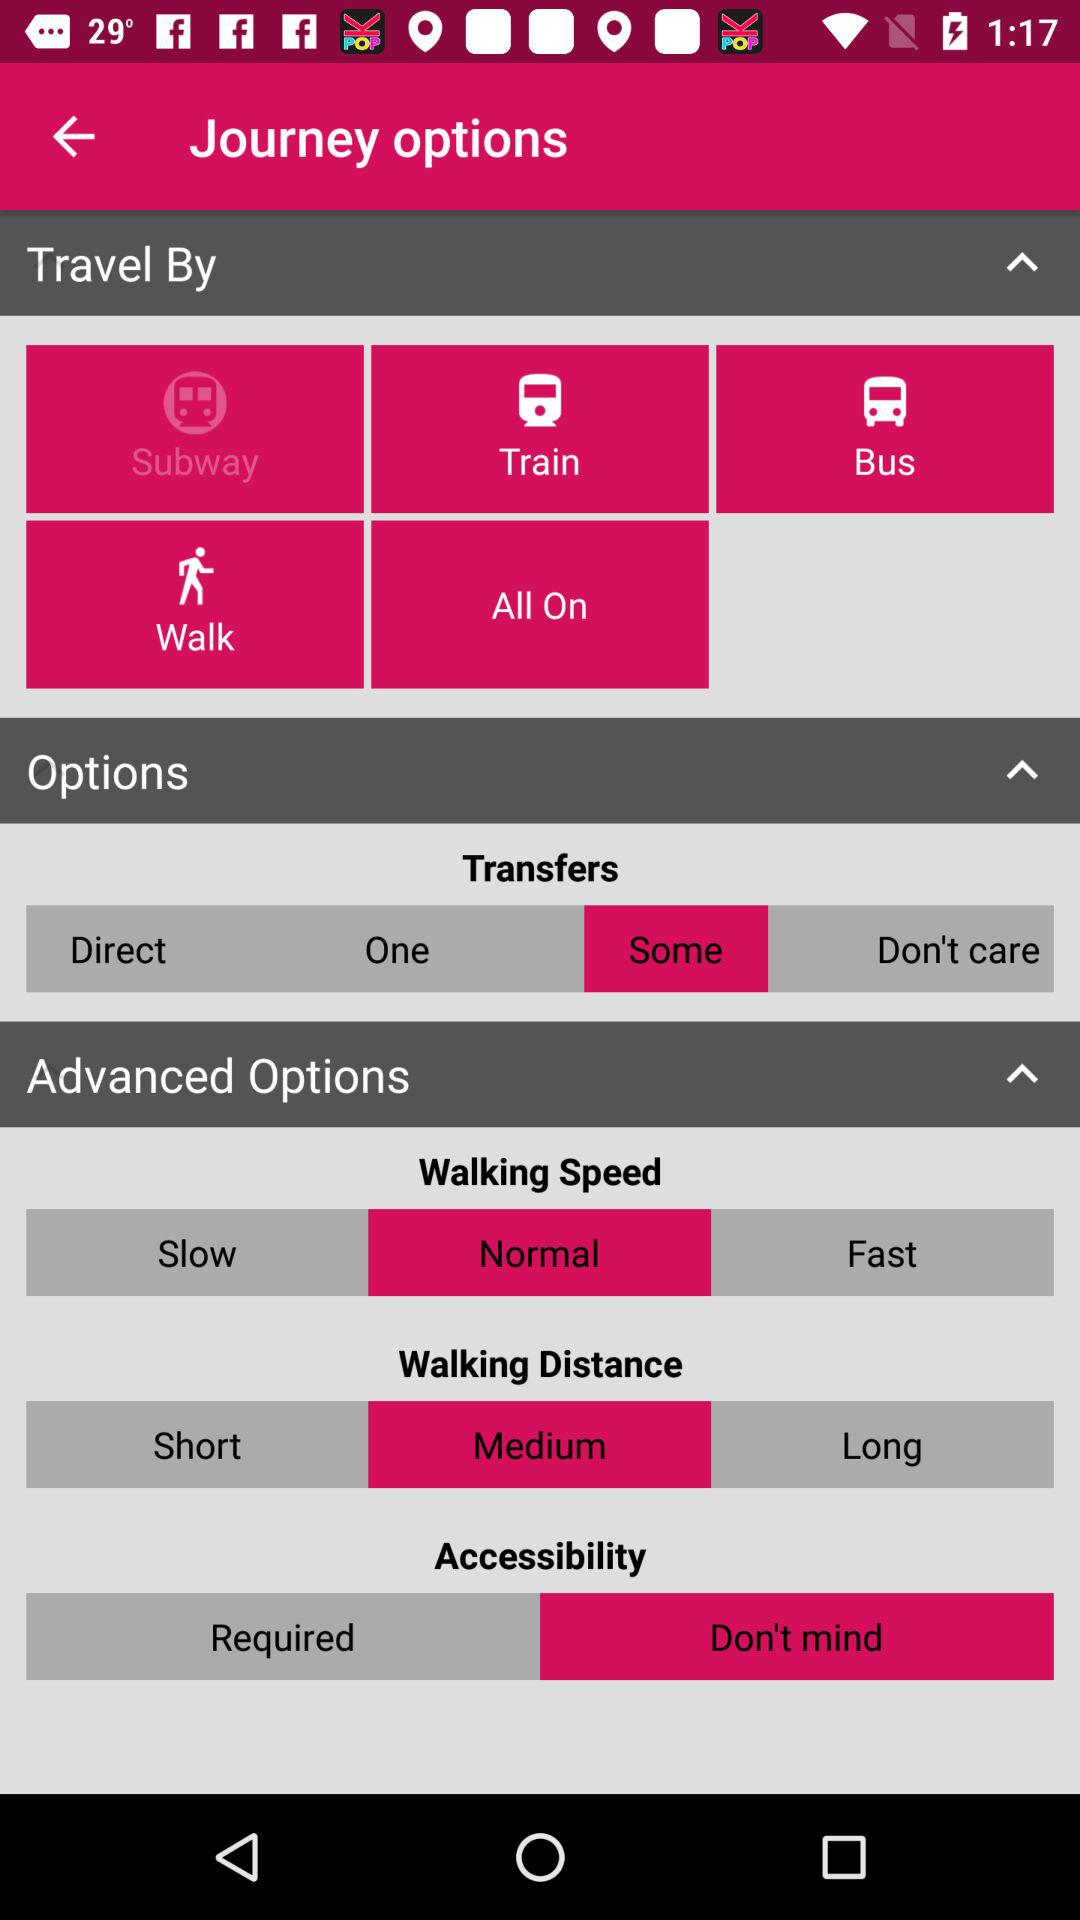How can we travel? You can travel via "Subway", "Train", "Bus", and "Walk". 